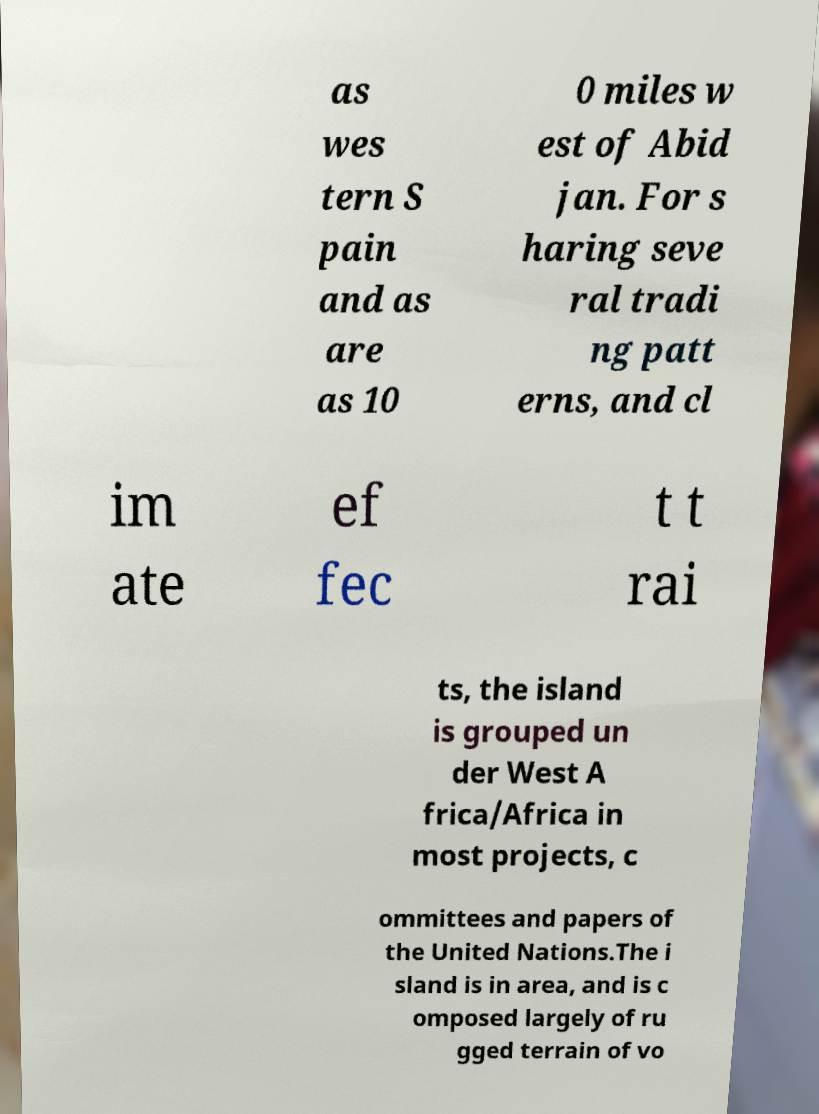For documentation purposes, I need the text within this image transcribed. Could you provide that? as wes tern S pain and as are as 10 0 miles w est of Abid jan. For s haring seve ral tradi ng patt erns, and cl im ate ef fec t t rai ts, the island is grouped un der West A frica/Africa in most projects, c ommittees and papers of the United Nations.The i sland is in area, and is c omposed largely of ru gged terrain of vo 